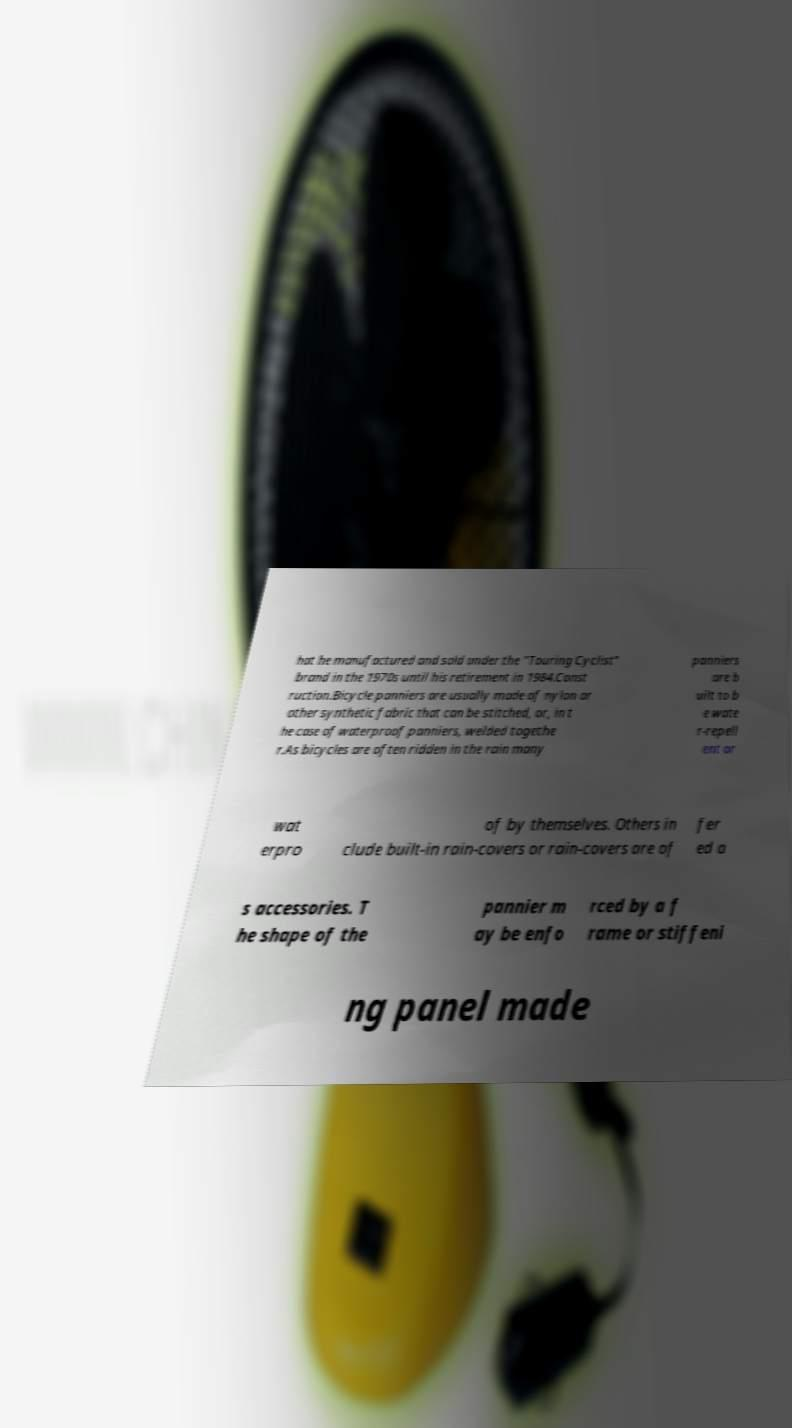Could you assist in decoding the text presented in this image and type it out clearly? hat he manufactured and sold under the "Touring Cyclist" brand in the 1970s until his retirement in 1984.Const ruction.Bicycle panniers are usually made of nylon or other synthetic fabric that can be stitched, or, in t he case of waterproof panniers, welded togethe r.As bicycles are often ridden in the rain many panniers are b uilt to b e wate r-repell ent or wat erpro of by themselves. Others in clude built-in rain-covers or rain-covers are of fer ed a s accessories. T he shape of the pannier m ay be enfo rced by a f rame or stiffeni ng panel made 